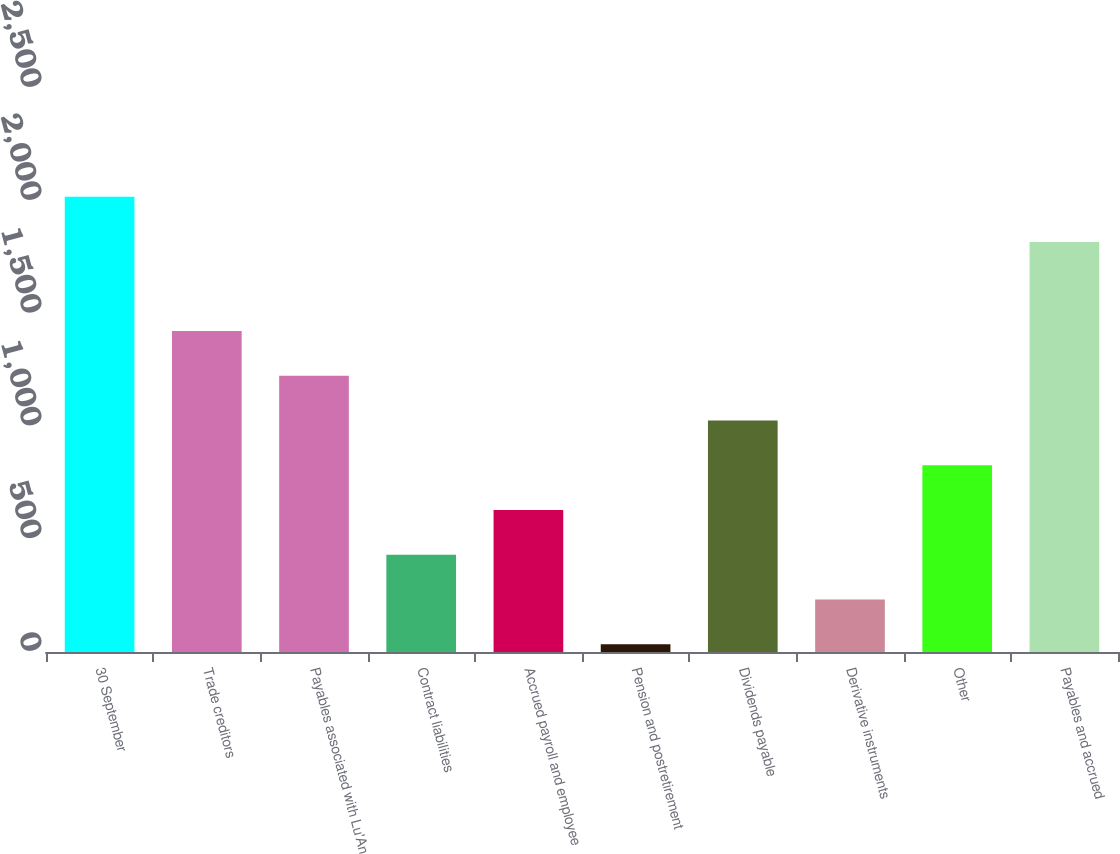Convert chart to OTSL. <chart><loc_0><loc_0><loc_500><loc_500><bar_chart><fcel>30 September<fcel>Trade creditors<fcel>Payables associated with Lu'An<fcel>Contract liabilities<fcel>Accrued payroll and employee<fcel>Pension and postretirement<fcel>Dividends payable<fcel>Derivative instruments<fcel>Other<fcel>Payables and accrued<nl><fcel>2018<fcel>1422.83<fcel>1224.44<fcel>430.88<fcel>629.27<fcel>34.1<fcel>1026.05<fcel>232.49<fcel>827.66<fcel>1817.8<nl></chart> 